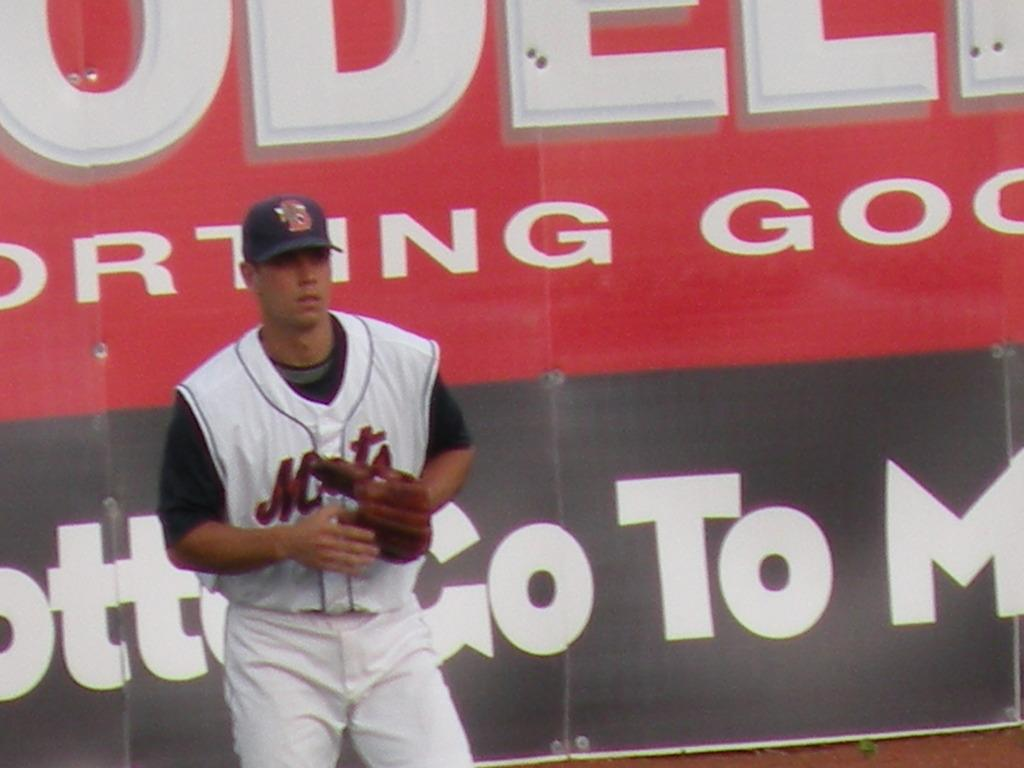Provide a one-sentence caption for the provided image. A baseball player for the Mets stands in front og a large billboard. 